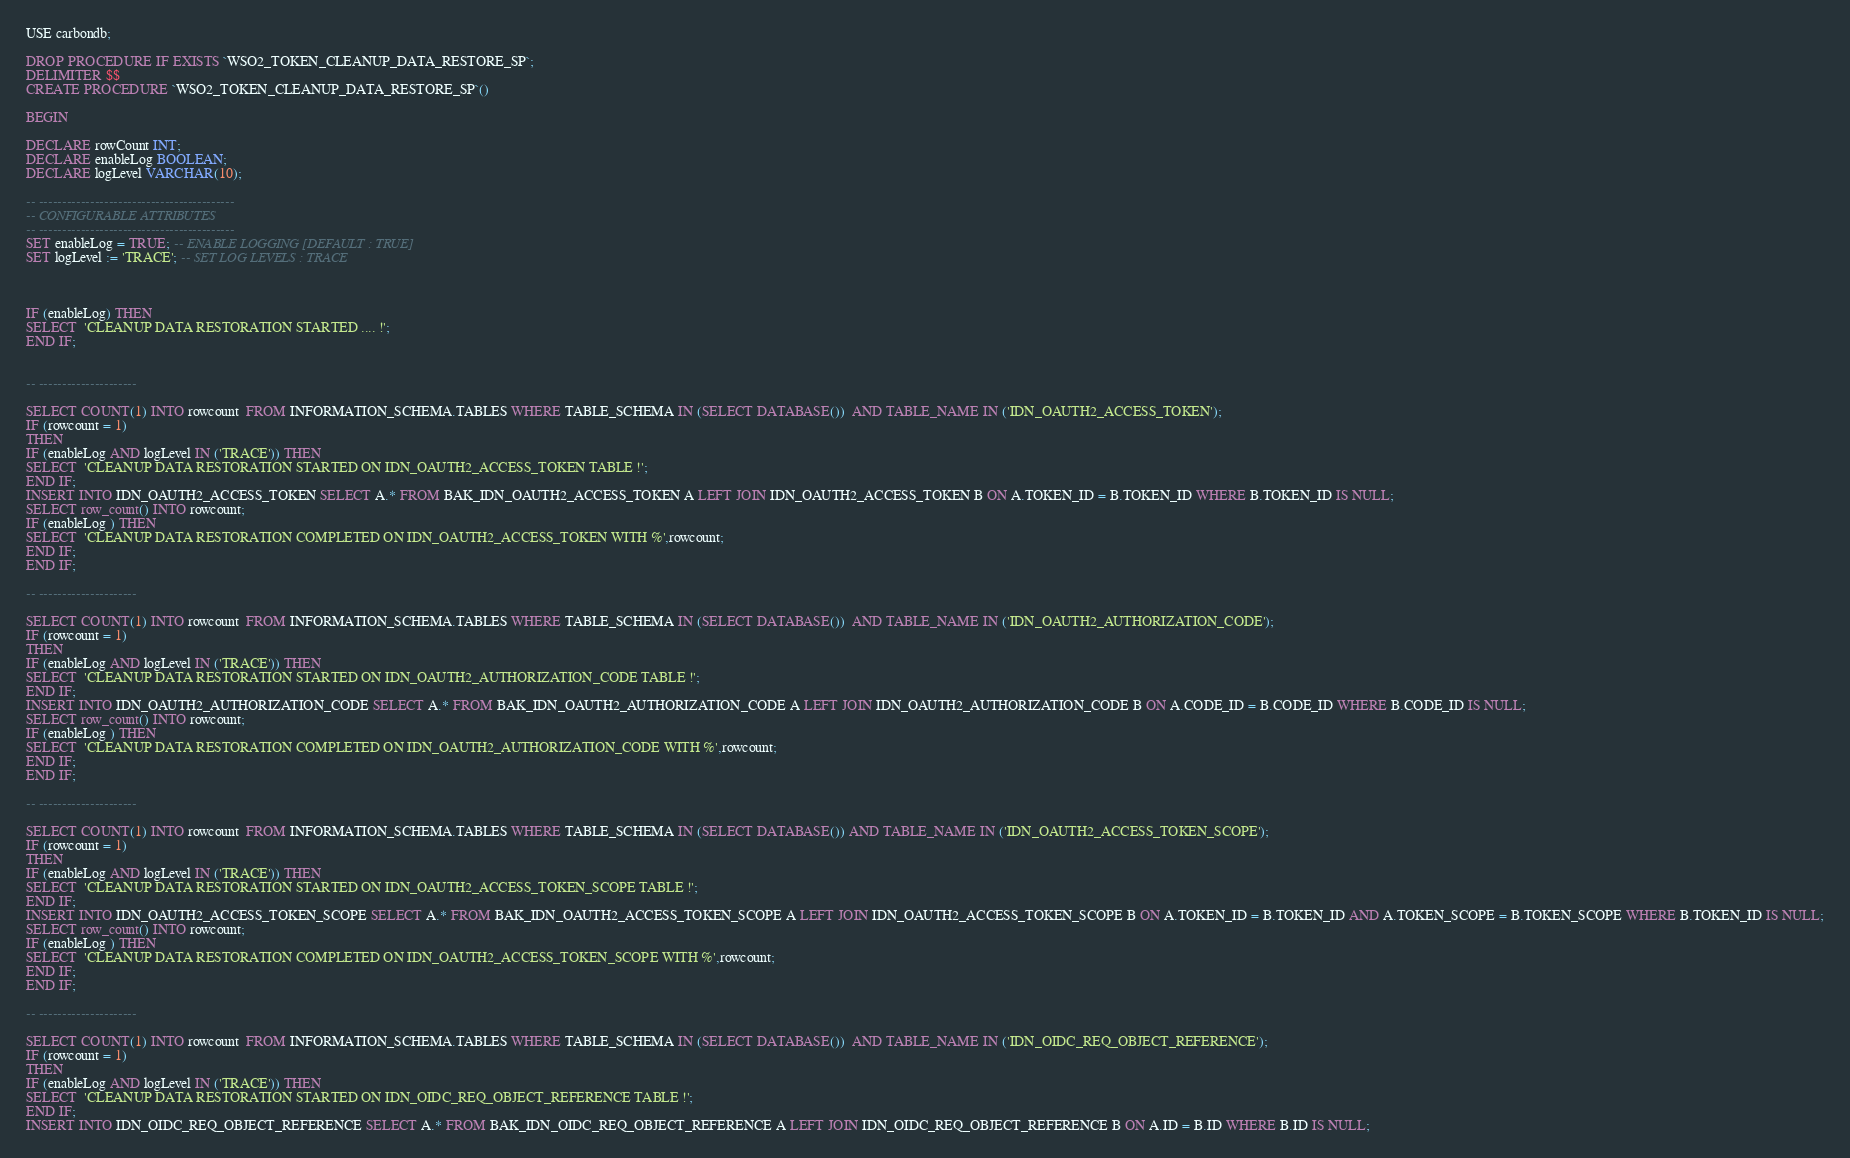Convert code to text. <code><loc_0><loc_0><loc_500><loc_500><_SQL_>USE carbondb;

DROP PROCEDURE IF EXISTS `WSO2_TOKEN_CLEANUP_DATA_RESTORE_SP`;
DELIMITER $$
CREATE PROCEDURE `WSO2_TOKEN_CLEANUP_DATA_RESTORE_SP`()

BEGIN

DECLARE rowCount INT;
DECLARE enableLog BOOLEAN;
DECLARE logLevel VARCHAR(10);

-- ------------------------------------------
-- CONFIGURABLE ATTRIBUTES
-- ------------------------------------------
SET enableLog = TRUE; -- ENABLE LOGGING [DEFAULT : TRUE]
SET logLevel := 'TRACE'; -- SET LOG LEVELS : TRACE



IF (enableLog) THEN
SELECT  'CLEANUP DATA RESTORATION STARTED .... !';
END IF;


-- ---------------------

SELECT COUNT(1) INTO rowcount  FROM INFORMATION_SCHEMA.TABLES WHERE TABLE_SCHEMA IN (SELECT DATABASE())  AND TABLE_NAME IN ('IDN_OAUTH2_ACCESS_TOKEN');
IF (rowcount = 1)
THEN
IF (enableLog AND logLevel IN ('TRACE')) THEN
SELECT  'CLEANUP DATA RESTORATION STARTED ON IDN_OAUTH2_ACCESS_TOKEN TABLE !';
END IF;
INSERT INTO IDN_OAUTH2_ACCESS_TOKEN SELECT A.* FROM BAK_IDN_OAUTH2_ACCESS_TOKEN A LEFT JOIN IDN_OAUTH2_ACCESS_TOKEN B ON A.TOKEN_ID = B.TOKEN_ID WHERE B.TOKEN_ID IS NULL;
SELECT row_count() INTO rowcount;
IF (enableLog ) THEN
SELECT  'CLEANUP DATA RESTORATION COMPLETED ON IDN_OAUTH2_ACCESS_TOKEN WITH %',rowcount;
END IF;
END IF;

-- ---------------------

SELECT COUNT(1) INTO rowcount  FROM INFORMATION_SCHEMA.TABLES WHERE TABLE_SCHEMA IN (SELECT DATABASE())  AND TABLE_NAME IN ('IDN_OAUTH2_AUTHORIZATION_CODE');
IF (rowcount = 1)
THEN
IF (enableLog AND logLevel IN ('TRACE')) THEN
SELECT  'CLEANUP DATA RESTORATION STARTED ON IDN_OAUTH2_AUTHORIZATION_CODE TABLE !';
END IF;
INSERT INTO IDN_OAUTH2_AUTHORIZATION_CODE SELECT A.* FROM BAK_IDN_OAUTH2_AUTHORIZATION_CODE A LEFT JOIN IDN_OAUTH2_AUTHORIZATION_CODE B ON A.CODE_ID = B.CODE_ID WHERE B.CODE_ID IS NULL;
SELECT row_count() INTO rowcount;
IF (enableLog ) THEN
SELECT  'CLEANUP DATA RESTORATION COMPLETED ON IDN_OAUTH2_AUTHORIZATION_CODE WITH %',rowcount;
END IF;
END IF;

-- ---------------------

SELECT COUNT(1) INTO rowcount  FROM INFORMATION_SCHEMA.TABLES WHERE TABLE_SCHEMA IN (SELECT DATABASE()) AND TABLE_NAME IN ('IDN_OAUTH2_ACCESS_TOKEN_SCOPE');
IF (rowcount = 1)
THEN
IF (enableLog AND logLevel IN ('TRACE')) THEN
SELECT  'CLEANUP DATA RESTORATION STARTED ON IDN_OAUTH2_ACCESS_TOKEN_SCOPE TABLE !';
END IF;
INSERT INTO IDN_OAUTH2_ACCESS_TOKEN_SCOPE SELECT A.* FROM BAK_IDN_OAUTH2_ACCESS_TOKEN_SCOPE A LEFT JOIN IDN_OAUTH2_ACCESS_TOKEN_SCOPE B ON A.TOKEN_ID = B.TOKEN_ID AND A.TOKEN_SCOPE = B.TOKEN_SCOPE WHERE B.TOKEN_ID IS NULL;
SELECT row_count() INTO rowcount;
IF (enableLog ) THEN
SELECT  'CLEANUP DATA RESTORATION COMPLETED ON IDN_OAUTH2_ACCESS_TOKEN_SCOPE WITH %',rowcount;
END IF;
END IF;

-- ---------------------

SELECT COUNT(1) INTO rowcount  FROM INFORMATION_SCHEMA.TABLES WHERE TABLE_SCHEMA IN (SELECT DATABASE())  AND TABLE_NAME IN ('IDN_OIDC_REQ_OBJECT_REFERENCE');
IF (rowcount = 1)
THEN
IF (enableLog AND logLevel IN ('TRACE')) THEN
SELECT  'CLEANUP DATA RESTORATION STARTED ON IDN_OIDC_REQ_OBJECT_REFERENCE TABLE !';
END IF;
INSERT INTO IDN_OIDC_REQ_OBJECT_REFERENCE SELECT A.* FROM BAK_IDN_OIDC_REQ_OBJECT_REFERENCE A LEFT JOIN IDN_OIDC_REQ_OBJECT_REFERENCE B ON A.ID = B.ID WHERE B.ID IS NULL;</code> 